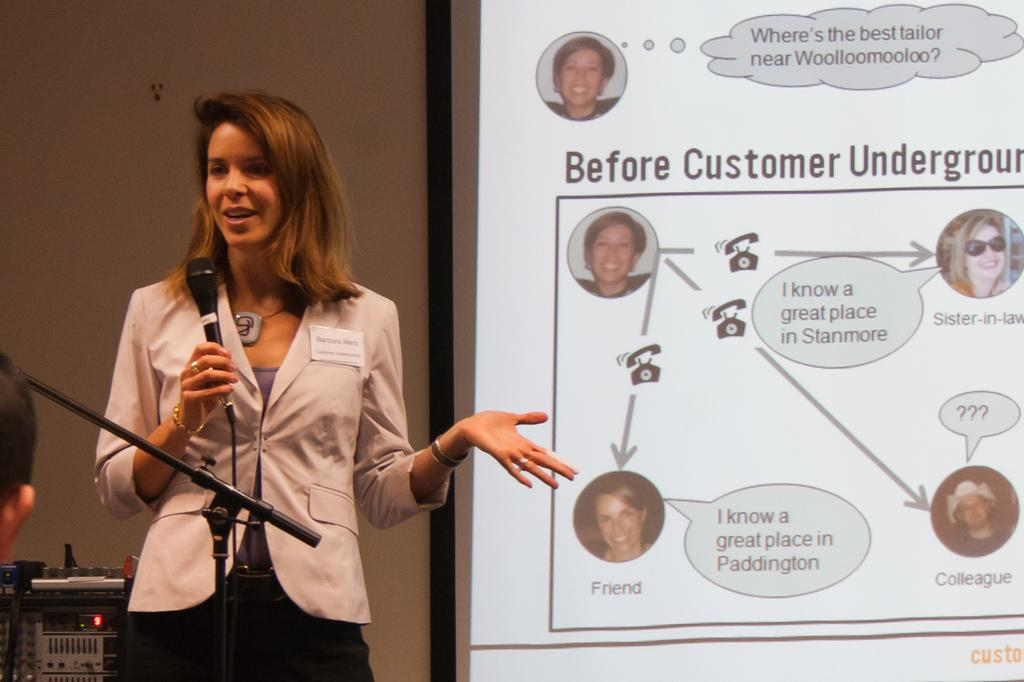Who is the main subject in the image? There is a lady in the image. What is the lady wearing? The lady is wearing a jacket. What is the lady doing in the image? The lady is standing, holding a mic in her hand, and talking. Can you describe the object in the left bottom corner of the image? There is a box in the left bottom corner of the image. What else can be seen on the screen in the image? There are persons visible on a screen in the image. What type of giants can be seen in the image? There are no giants present in the image. What is the lady discussing in the image, related to the war? The image does not provide any information about a war or the lady's discussion topic. 